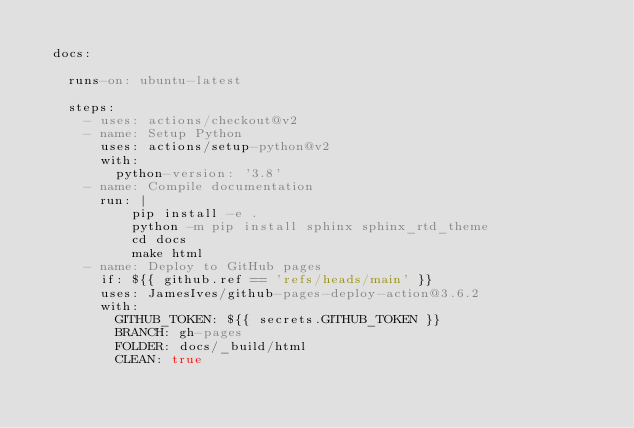Convert code to text. <code><loc_0><loc_0><loc_500><loc_500><_YAML_>  
  docs:

    runs-on: ubuntu-latest

    steps:
      - uses: actions/checkout@v2
      - name: Setup Python
        uses: actions/setup-python@v2
        with:
          python-version: '3.8'
      - name: Compile documentation
        run: |
            pip install -e .
            python -m pip install sphinx sphinx_rtd_theme
            cd docs
            make html
      - name: Deploy to GitHub pages
        if: ${{ github.ref == 'refs/heads/main' }}
        uses: JamesIves/github-pages-deploy-action@3.6.2
        with:
          GITHUB_TOKEN: ${{ secrets.GITHUB_TOKEN }}
          BRANCH: gh-pages
          FOLDER: docs/_build/html
          CLEAN: true</code> 